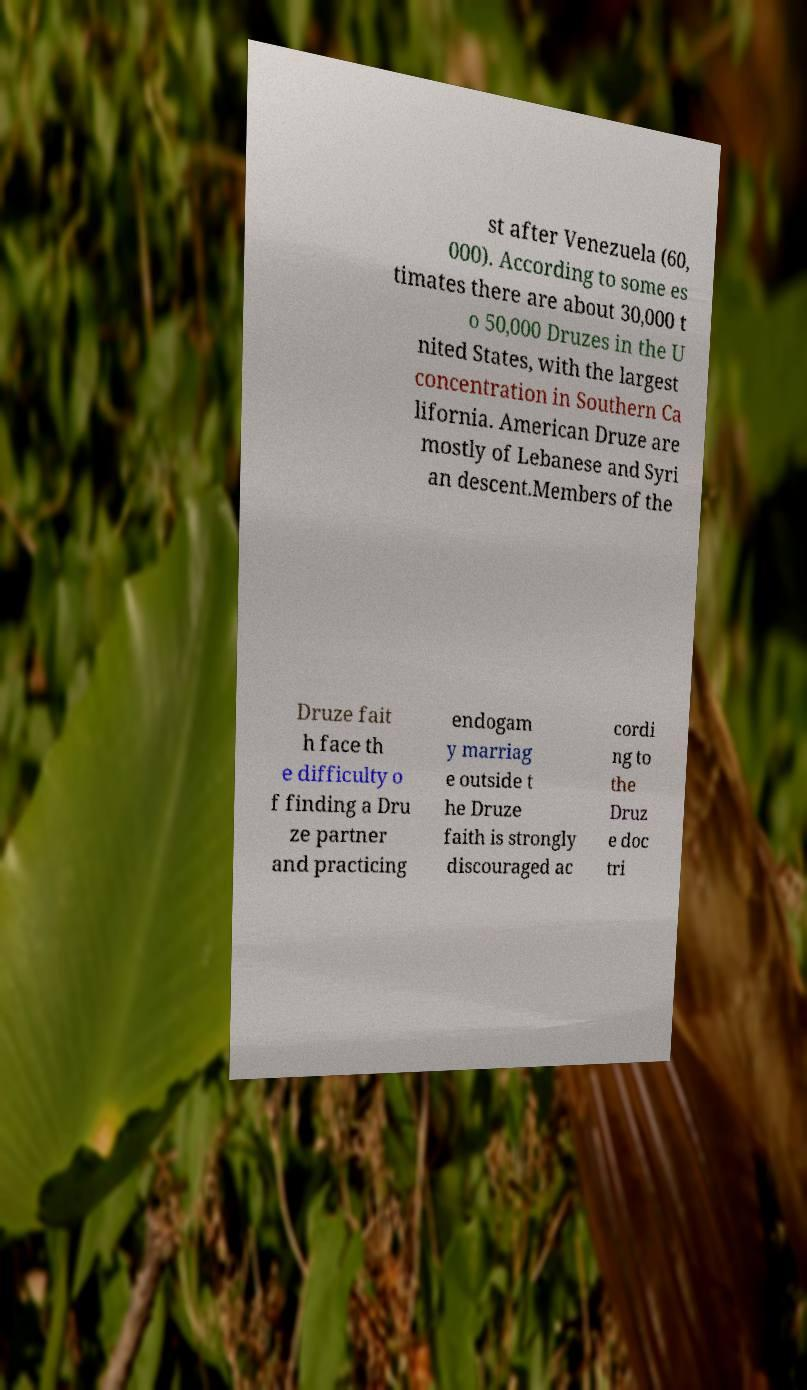For documentation purposes, I need the text within this image transcribed. Could you provide that? st after Venezuela (60, 000). According to some es timates there are about 30,000 t o 50,000 Druzes in the U nited States, with the largest concentration in Southern Ca lifornia. American Druze are mostly of Lebanese and Syri an descent.Members of the Druze fait h face th e difficulty o f finding a Dru ze partner and practicing endogam y marriag e outside t he Druze faith is strongly discouraged ac cordi ng to the Druz e doc tri 